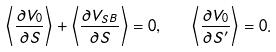<formula> <loc_0><loc_0><loc_500><loc_500>\left < \frac { \partial V _ { 0 } } { \partial S } \right > + \left < \frac { \partial V _ { S B } } { \partial S } \right > = 0 , \quad \left < \frac { \partial V _ { 0 } } { \partial S ^ { \prime } } \right > = 0 .</formula> 